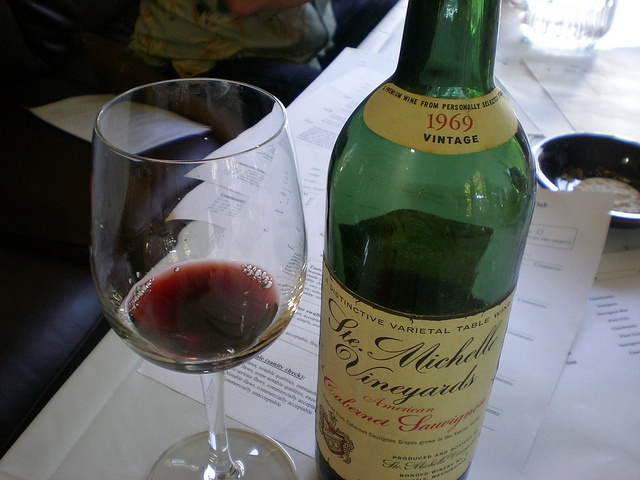Describe the objects in this image and their specific colors. I can see bottle in black, darkgreen, gray, and olive tones, wine glass in black, gray, and darkgray tones, couch in black, gray, and darkblue tones, people in black, gray, maroon, and blue tones, and dining table in black and gray tones in this image. 